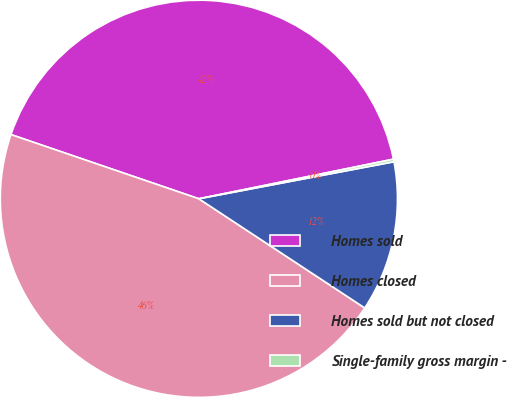<chart> <loc_0><loc_0><loc_500><loc_500><pie_chart><fcel>Homes sold<fcel>Homes closed<fcel>Homes sold but not closed<fcel>Single-family gross margin -<nl><fcel>41.56%<fcel>45.97%<fcel>12.25%<fcel>0.21%<nl></chart> 